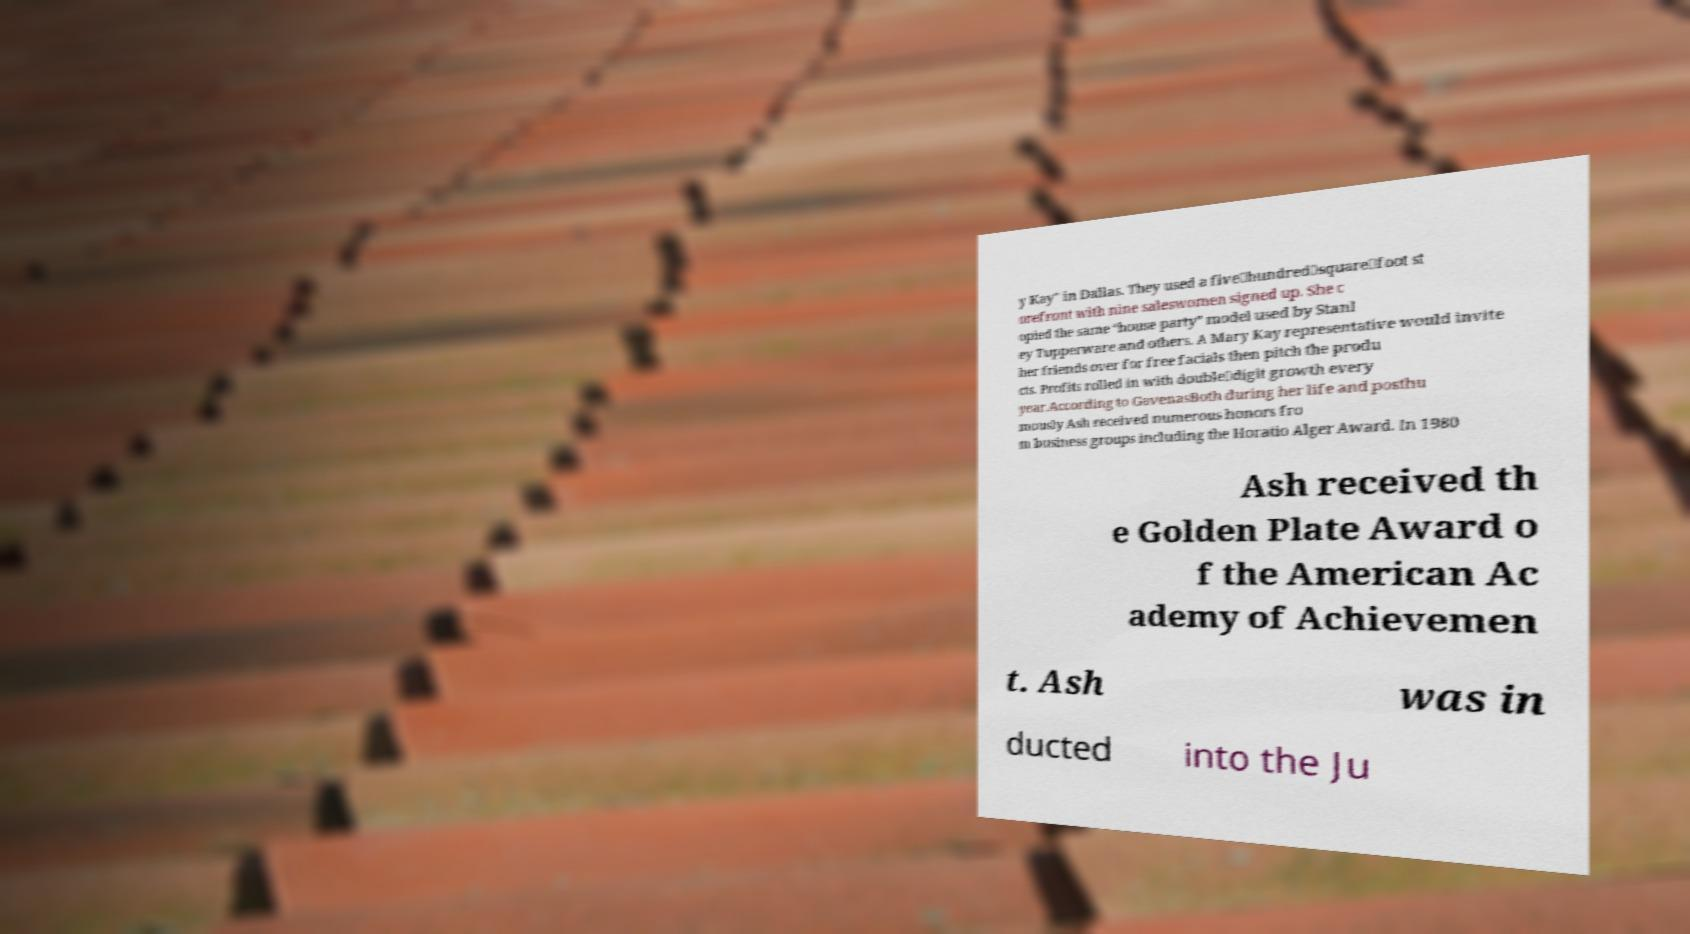Please identify and transcribe the text found in this image. y Kay" in Dallas. They used a five‐hundred‐square‐foot st orefront with nine saleswomen signed up. She c opied the same “house party” model used by Stanl ey Tupperware and others. A Mary Kay representative would invite her friends over for free facials then pitch the produ cts. Profits rolled in with double‐digit growth every year.According to GavenasBoth during her life and posthu mously Ash received numerous honors fro m business groups including the Horatio Alger Award. In 1980 Ash received th e Golden Plate Award o f the American Ac ademy of Achievemen t. Ash was in ducted into the Ju 